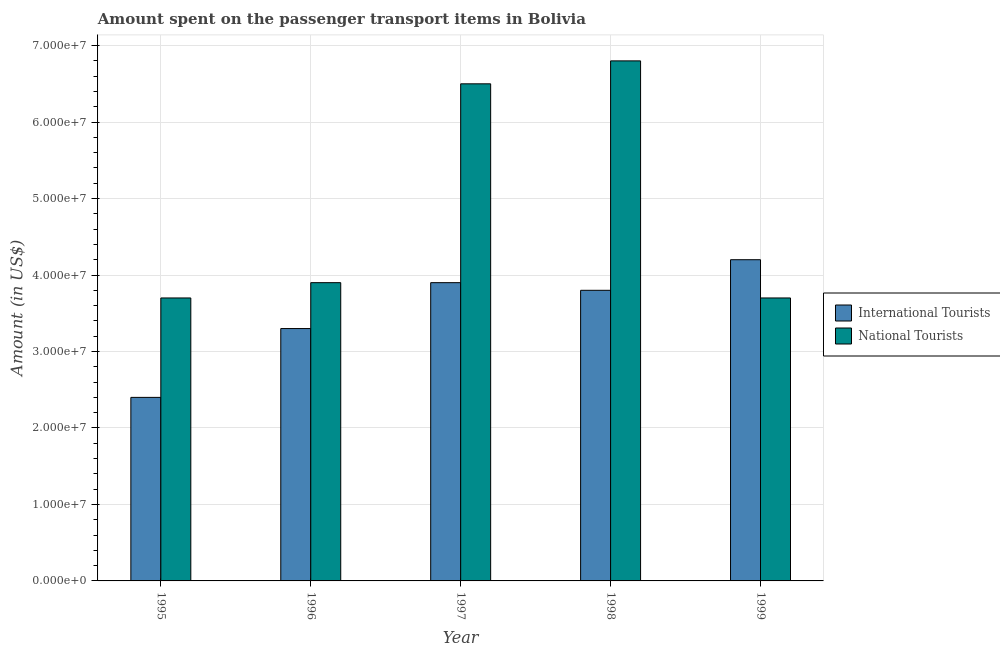How many different coloured bars are there?
Give a very brief answer. 2. How many groups of bars are there?
Give a very brief answer. 5. What is the amount spent on transport items of international tourists in 1998?
Make the answer very short. 3.80e+07. Across all years, what is the maximum amount spent on transport items of national tourists?
Offer a very short reply. 6.80e+07. Across all years, what is the minimum amount spent on transport items of international tourists?
Offer a very short reply. 2.40e+07. In which year was the amount spent on transport items of national tourists minimum?
Give a very brief answer. 1995. What is the total amount spent on transport items of international tourists in the graph?
Offer a very short reply. 1.76e+08. What is the difference between the amount spent on transport items of international tourists in 1996 and that in 1998?
Make the answer very short. -5.00e+06. What is the difference between the amount spent on transport items of international tourists in 1995 and the amount spent on transport items of national tourists in 1998?
Keep it short and to the point. -1.40e+07. What is the average amount spent on transport items of international tourists per year?
Your answer should be very brief. 3.52e+07. In the year 1997, what is the difference between the amount spent on transport items of international tourists and amount spent on transport items of national tourists?
Provide a short and direct response. 0. In how many years, is the amount spent on transport items of national tourists greater than 30000000 US$?
Offer a very short reply. 5. What is the ratio of the amount spent on transport items of international tourists in 1996 to that in 1998?
Keep it short and to the point. 0.87. What is the difference between the highest and the lowest amount spent on transport items of international tourists?
Keep it short and to the point. 1.80e+07. What does the 2nd bar from the left in 1998 represents?
Your answer should be very brief. National Tourists. What does the 1st bar from the right in 1999 represents?
Provide a short and direct response. National Tourists. Are all the bars in the graph horizontal?
Your answer should be very brief. No. How many years are there in the graph?
Keep it short and to the point. 5. What is the difference between two consecutive major ticks on the Y-axis?
Offer a terse response. 1.00e+07. Where does the legend appear in the graph?
Provide a succinct answer. Center right. How many legend labels are there?
Offer a terse response. 2. What is the title of the graph?
Provide a short and direct response. Amount spent on the passenger transport items in Bolivia. What is the label or title of the Y-axis?
Provide a short and direct response. Amount (in US$). What is the Amount (in US$) in International Tourists in 1995?
Give a very brief answer. 2.40e+07. What is the Amount (in US$) of National Tourists in 1995?
Provide a short and direct response. 3.70e+07. What is the Amount (in US$) of International Tourists in 1996?
Provide a short and direct response. 3.30e+07. What is the Amount (in US$) in National Tourists in 1996?
Your response must be concise. 3.90e+07. What is the Amount (in US$) in International Tourists in 1997?
Offer a very short reply. 3.90e+07. What is the Amount (in US$) in National Tourists in 1997?
Ensure brevity in your answer.  6.50e+07. What is the Amount (in US$) in International Tourists in 1998?
Keep it short and to the point. 3.80e+07. What is the Amount (in US$) of National Tourists in 1998?
Give a very brief answer. 6.80e+07. What is the Amount (in US$) of International Tourists in 1999?
Make the answer very short. 4.20e+07. What is the Amount (in US$) in National Tourists in 1999?
Make the answer very short. 3.70e+07. Across all years, what is the maximum Amount (in US$) of International Tourists?
Make the answer very short. 4.20e+07. Across all years, what is the maximum Amount (in US$) of National Tourists?
Your answer should be compact. 6.80e+07. Across all years, what is the minimum Amount (in US$) of International Tourists?
Ensure brevity in your answer.  2.40e+07. Across all years, what is the minimum Amount (in US$) in National Tourists?
Your response must be concise. 3.70e+07. What is the total Amount (in US$) of International Tourists in the graph?
Offer a terse response. 1.76e+08. What is the total Amount (in US$) in National Tourists in the graph?
Your answer should be compact. 2.46e+08. What is the difference between the Amount (in US$) in International Tourists in 1995 and that in 1996?
Make the answer very short. -9.00e+06. What is the difference between the Amount (in US$) in National Tourists in 1995 and that in 1996?
Your answer should be very brief. -2.00e+06. What is the difference between the Amount (in US$) in International Tourists in 1995 and that in 1997?
Provide a succinct answer. -1.50e+07. What is the difference between the Amount (in US$) in National Tourists in 1995 and that in 1997?
Keep it short and to the point. -2.80e+07. What is the difference between the Amount (in US$) of International Tourists in 1995 and that in 1998?
Your answer should be compact. -1.40e+07. What is the difference between the Amount (in US$) in National Tourists in 1995 and that in 1998?
Your answer should be very brief. -3.10e+07. What is the difference between the Amount (in US$) of International Tourists in 1995 and that in 1999?
Offer a very short reply. -1.80e+07. What is the difference between the Amount (in US$) of International Tourists in 1996 and that in 1997?
Provide a short and direct response. -6.00e+06. What is the difference between the Amount (in US$) in National Tourists in 1996 and that in 1997?
Your answer should be very brief. -2.60e+07. What is the difference between the Amount (in US$) in International Tourists in 1996 and that in 1998?
Your answer should be compact. -5.00e+06. What is the difference between the Amount (in US$) of National Tourists in 1996 and that in 1998?
Offer a terse response. -2.90e+07. What is the difference between the Amount (in US$) in International Tourists in 1996 and that in 1999?
Offer a very short reply. -9.00e+06. What is the difference between the Amount (in US$) of National Tourists in 1996 and that in 1999?
Make the answer very short. 2.00e+06. What is the difference between the Amount (in US$) of International Tourists in 1997 and that in 1998?
Make the answer very short. 1.00e+06. What is the difference between the Amount (in US$) of National Tourists in 1997 and that in 1998?
Offer a terse response. -3.00e+06. What is the difference between the Amount (in US$) of International Tourists in 1997 and that in 1999?
Offer a very short reply. -3.00e+06. What is the difference between the Amount (in US$) of National Tourists in 1997 and that in 1999?
Offer a very short reply. 2.80e+07. What is the difference between the Amount (in US$) in National Tourists in 1998 and that in 1999?
Keep it short and to the point. 3.10e+07. What is the difference between the Amount (in US$) of International Tourists in 1995 and the Amount (in US$) of National Tourists in 1996?
Offer a very short reply. -1.50e+07. What is the difference between the Amount (in US$) of International Tourists in 1995 and the Amount (in US$) of National Tourists in 1997?
Offer a terse response. -4.10e+07. What is the difference between the Amount (in US$) of International Tourists in 1995 and the Amount (in US$) of National Tourists in 1998?
Your answer should be very brief. -4.40e+07. What is the difference between the Amount (in US$) of International Tourists in 1995 and the Amount (in US$) of National Tourists in 1999?
Your answer should be very brief. -1.30e+07. What is the difference between the Amount (in US$) in International Tourists in 1996 and the Amount (in US$) in National Tourists in 1997?
Your response must be concise. -3.20e+07. What is the difference between the Amount (in US$) of International Tourists in 1996 and the Amount (in US$) of National Tourists in 1998?
Ensure brevity in your answer.  -3.50e+07. What is the difference between the Amount (in US$) of International Tourists in 1996 and the Amount (in US$) of National Tourists in 1999?
Provide a succinct answer. -4.00e+06. What is the difference between the Amount (in US$) of International Tourists in 1997 and the Amount (in US$) of National Tourists in 1998?
Offer a very short reply. -2.90e+07. What is the average Amount (in US$) of International Tourists per year?
Give a very brief answer. 3.52e+07. What is the average Amount (in US$) of National Tourists per year?
Your response must be concise. 4.92e+07. In the year 1995, what is the difference between the Amount (in US$) of International Tourists and Amount (in US$) of National Tourists?
Give a very brief answer. -1.30e+07. In the year 1996, what is the difference between the Amount (in US$) in International Tourists and Amount (in US$) in National Tourists?
Your response must be concise. -6.00e+06. In the year 1997, what is the difference between the Amount (in US$) in International Tourists and Amount (in US$) in National Tourists?
Ensure brevity in your answer.  -2.60e+07. In the year 1998, what is the difference between the Amount (in US$) in International Tourists and Amount (in US$) in National Tourists?
Your answer should be compact. -3.00e+07. In the year 1999, what is the difference between the Amount (in US$) in International Tourists and Amount (in US$) in National Tourists?
Keep it short and to the point. 5.00e+06. What is the ratio of the Amount (in US$) in International Tourists in 1995 to that in 1996?
Your answer should be compact. 0.73. What is the ratio of the Amount (in US$) in National Tourists in 1995 to that in 1996?
Your answer should be very brief. 0.95. What is the ratio of the Amount (in US$) in International Tourists in 1995 to that in 1997?
Ensure brevity in your answer.  0.62. What is the ratio of the Amount (in US$) of National Tourists in 1995 to that in 1997?
Ensure brevity in your answer.  0.57. What is the ratio of the Amount (in US$) of International Tourists in 1995 to that in 1998?
Provide a succinct answer. 0.63. What is the ratio of the Amount (in US$) of National Tourists in 1995 to that in 1998?
Provide a short and direct response. 0.54. What is the ratio of the Amount (in US$) in International Tourists in 1996 to that in 1997?
Your answer should be very brief. 0.85. What is the ratio of the Amount (in US$) in International Tourists in 1996 to that in 1998?
Offer a terse response. 0.87. What is the ratio of the Amount (in US$) in National Tourists in 1996 to that in 1998?
Your response must be concise. 0.57. What is the ratio of the Amount (in US$) in International Tourists in 1996 to that in 1999?
Your answer should be compact. 0.79. What is the ratio of the Amount (in US$) of National Tourists in 1996 to that in 1999?
Keep it short and to the point. 1.05. What is the ratio of the Amount (in US$) of International Tourists in 1997 to that in 1998?
Offer a terse response. 1.03. What is the ratio of the Amount (in US$) in National Tourists in 1997 to that in 1998?
Offer a very short reply. 0.96. What is the ratio of the Amount (in US$) in International Tourists in 1997 to that in 1999?
Your response must be concise. 0.93. What is the ratio of the Amount (in US$) in National Tourists in 1997 to that in 1999?
Give a very brief answer. 1.76. What is the ratio of the Amount (in US$) of International Tourists in 1998 to that in 1999?
Make the answer very short. 0.9. What is the ratio of the Amount (in US$) in National Tourists in 1998 to that in 1999?
Offer a very short reply. 1.84. What is the difference between the highest and the second highest Amount (in US$) of National Tourists?
Offer a terse response. 3.00e+06. What is the difference between the highest and the lowest Amount (in US$) of International Tourists?
Your answer should be very brief. 1.80e+07. What is the difference between the highest and the lowest Amount (in US$) of National Tourists?
Keep it short and to the point. 3.10e+07. 